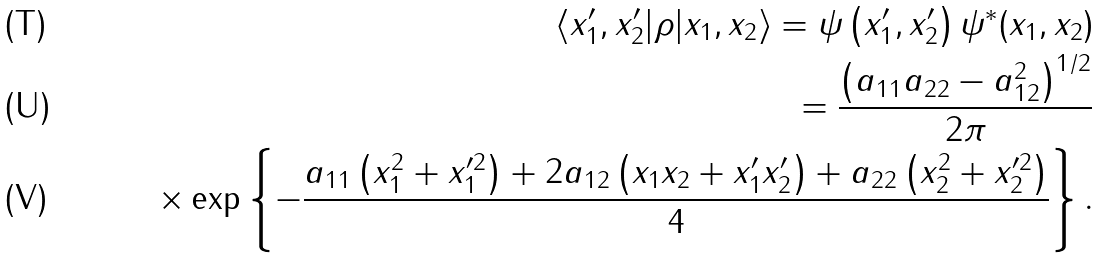Convert formula to latex. <formula><loc_0><loc_0><loc_500><loc_500>\langle x ^ { \prime } _ { 1 } , x ^ { \prime } _ { 2 } | \rho | x _ { 1 } , x _ { 2 } \rangle = \psi \left ( x ^ { \prime } _ { 1 } , x ^ { \prime } _ { 2 } \right ) \psi ^ { * } ( x _ { 1 } , x _ { 2 } ) \\ = \frac { \left ( a _ { 1 1 } a _ { 2 2 } - a ^ { 2 } _ { 1 2 } \right ) ^ { 1 / 2 } } { 2 \pi } \\ \times \exp \left \{ - \frac { a _ { 1 1 } \left ( x ^ { 2 } _ { 1 } + x ^ { \prime 2 } _ { 1 } \right ) + 2 a _ { 1 2 } \left ( x _ { 1 } x _ { 2 } + x ^ { \prime } _ { 1 } x ^ { \prime } _ { 2 } \right ) + a _ { 2 2 } \left ( x ^ { 2 } _ { 2 } + x ^ { \prime 2 } _ { 2 } \right ) } { 4 } \right \} .</formula> 